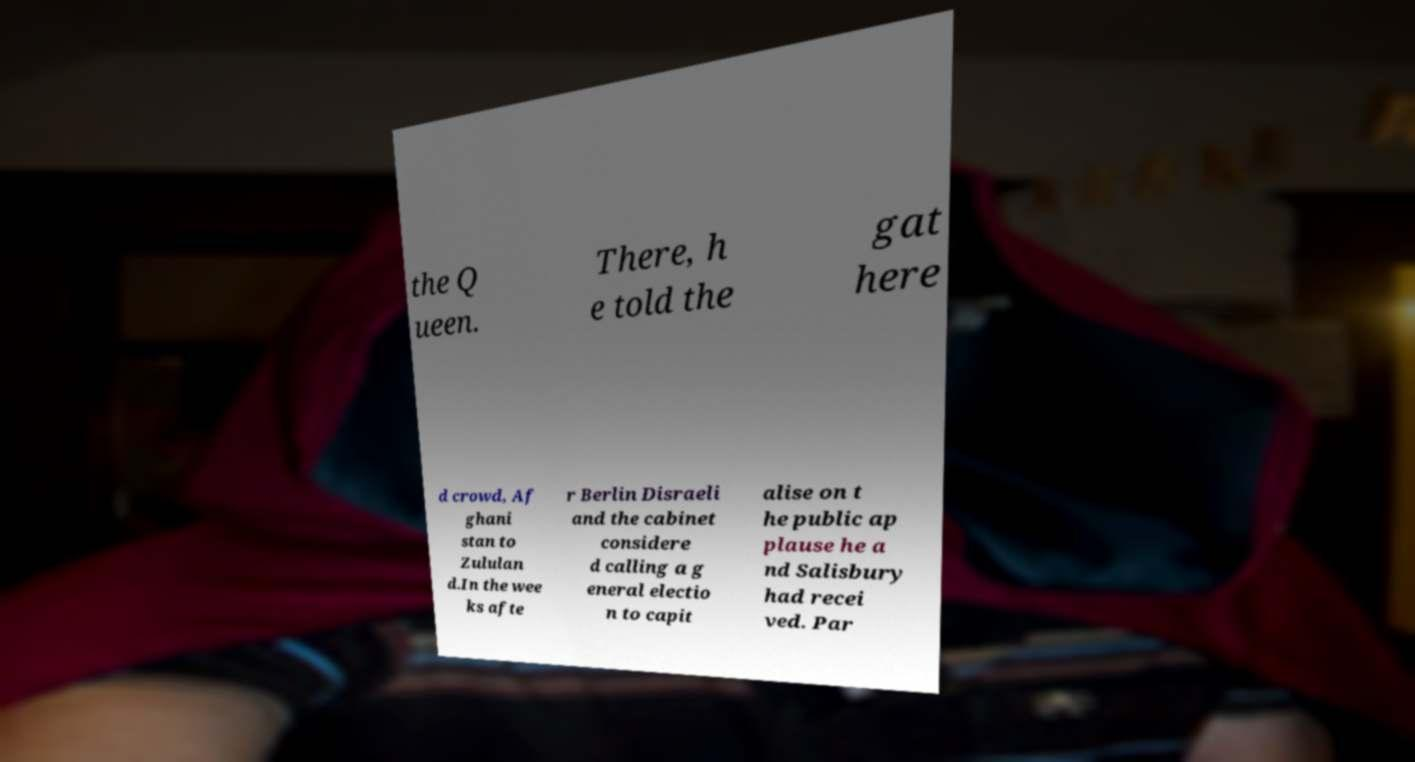What messages or text are displayed in this image? I need them in a readable, typed format. the Q ueen. There, h e told the gat here d crowd, Af ghani stan to Zululan d.In the wee ks afte r Berlin Disraeli and the cabinet considere d calling a g eneral electio n to capit alise on t he public ap plause he a nd Salisbury had recei ved. Par 